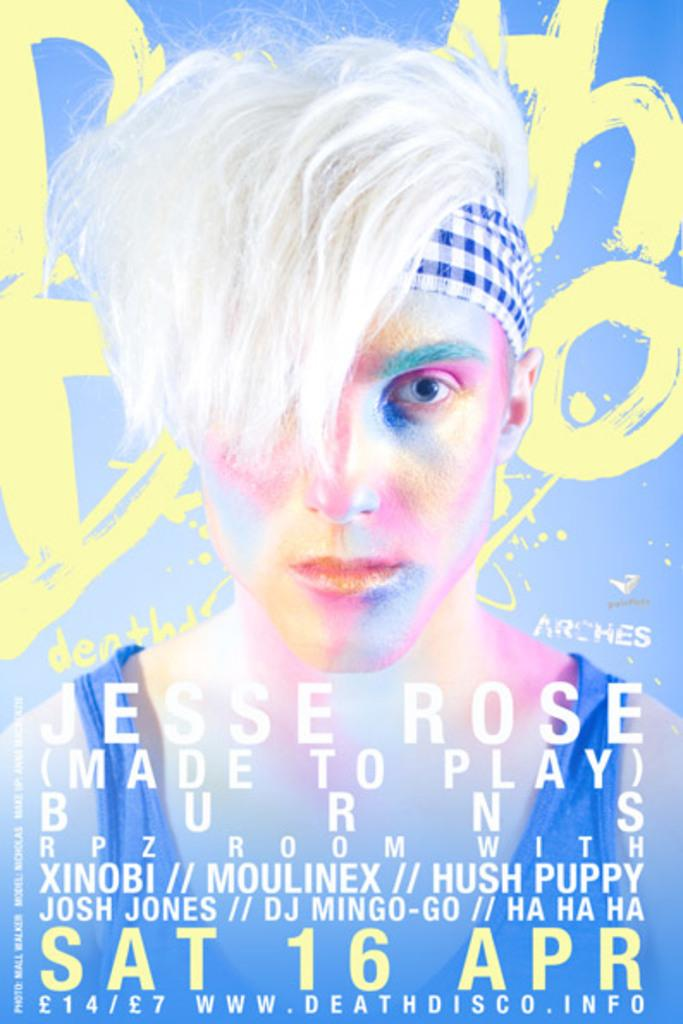What is the main subject of the image? There is a person in the image. What is in front of the person? There is text in front of the person. What can be seen behind the person? There is text visible behind the person. What color is the background of the image? The background of the image is blue. What type of jar is being attacked by the person in the image? There is no jar present in the image, nor is there any indication of an attack. 